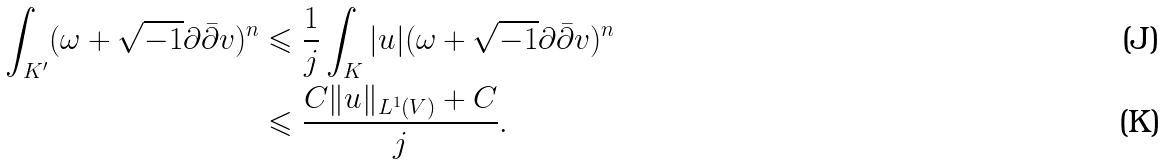Convert formula to latex. <formula><loc_0><loc_0><loc_500><loc_500>\int _ { K ^ { \prime } } ( \omega + \sqrt { - 1 } \partial \bar { \partial } v ) ^ { n } & \leqslant \frac { 1 } { j } \int _ { K } | u | ( \omega + \sqrt { - 1 } \partial \bar { \partial } v ) ^ { n } \\ & \leqslant \frac { C \| u \| _ { L ^ { 1 } ( V ) } + C } { j } .</formula> 